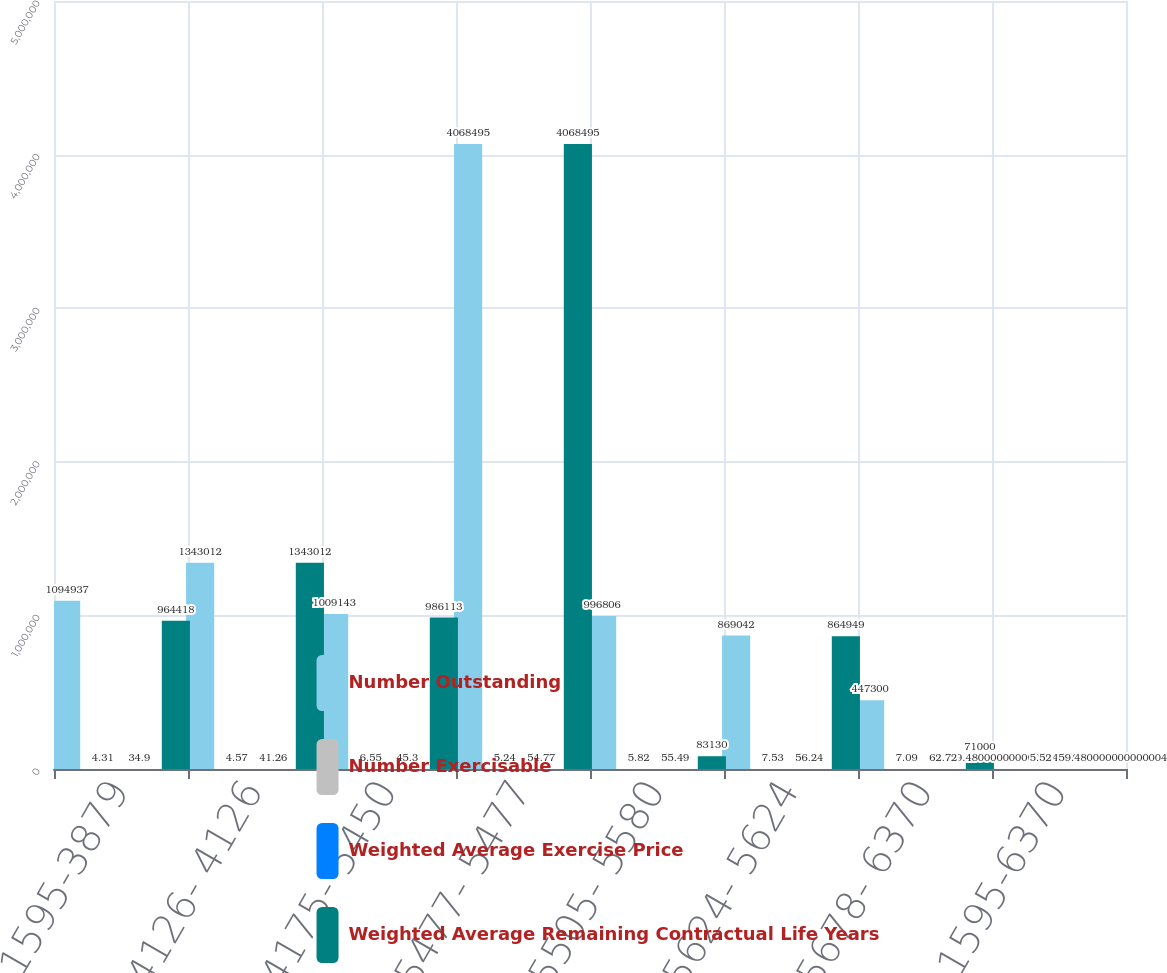Convert chart to OTSL. <chart><loc_0><loc_0><loc_500><loc_500><stacked_bar_chart><ecel><fcel>1595-3879<fcel>4126- 4126<fcel>4175- 5450<fcel>5477- 5477<fcel>5505- 5580<fcel>5624- 5624<fcel>5678- 6370<fcel>1595-6370<nl><fcel>Number Outstanding<fcel>1.09494e+06<fcel>1.34301e+06<fcel>1.00914e+06<fcel>4.0685e+06<fcel>996806<fcel>869042<fcel>447300<fcel>59.48<nl><fcel>Number Exercisable<fcel>4.31<fcel>4.57<fcel>6.55<fcel>5.24<fcel>5.82<fcel>7.53<fcel>7.09<fcel>5.52<nl><fcel>Weighted Average Exercise Price<fcel>34.9<fcel>41.26<fcel>45.3<fcel>54.77<fcel>55.49<fcel>56.24<fcel>62.72<fcel>50.3<nl><fcel>Weighted Average Remaining Contractual Life Years<fcel>964418<fcel>1.34301e+06<fcel>986113<fcel>4.0685e+06<fcel>83130<fcel>864949<fcel>71000<fcel>59.48<nl></chart> 